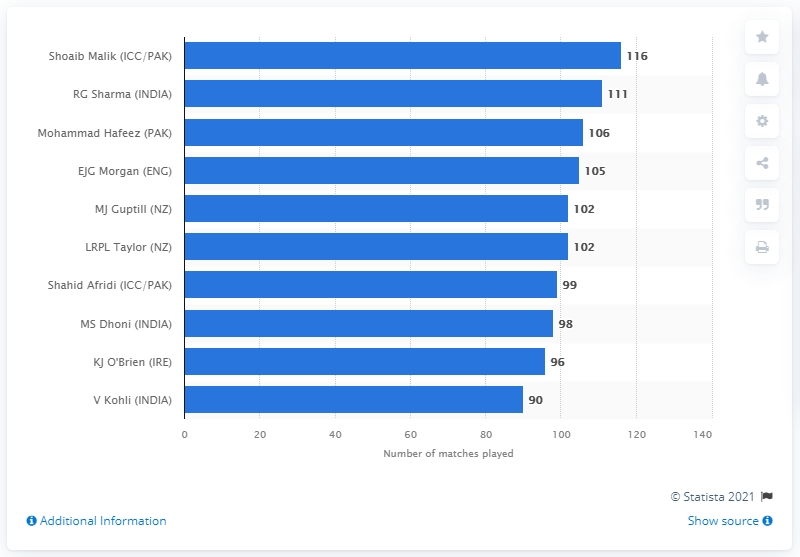Identify some key points in this picture. Shoaib Malik played a total of 116 international T20 matches between 2006 and 2020. 